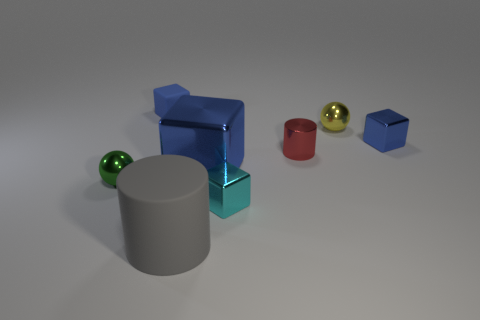Subtract all purple spheres. How many blue cubes are left? 3 Subtract all metallic cubes. How many cubes are left? 1 Add 1 red cylinders. How many objects exist? 9 Subtract all green blocks. Subtract all blue cylinders. How many blocks are left? 4 Subtract all balls. How many objects are left? 6 Add 5 matte cubes. How many matte cubes exist? 6 Subtract 0 gray spheres. How many objects are left? 8 Subtract all matte things. Subtract all shiny cubes. How many objects are left? 3 Add 6 small blue blocks. How many small blue blocks are left? 8 